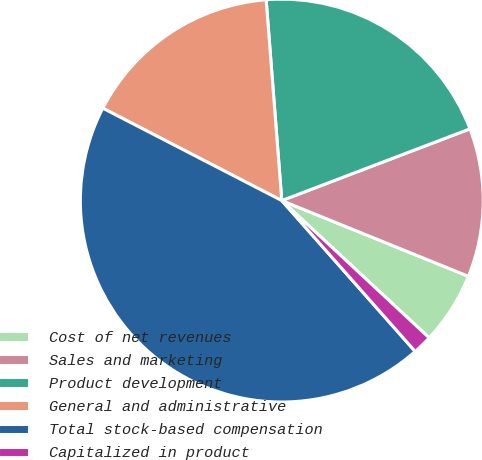Convert chart. <chart><loc_0><loc_0><loc_500><loc_500><pie_chart><fcel>Cost of net revenues<fcel>Sales and marketing<fcel>Product development<fcel>General and administrative<fcel>Total stock-based compensation<fcel>Capitalized in product<nl><fcel>5.8%<fcel>11.93%<fcel>20.44%<fcel>16.18%<fcel>44.11%<fcel>1.54%<nl></chart> 